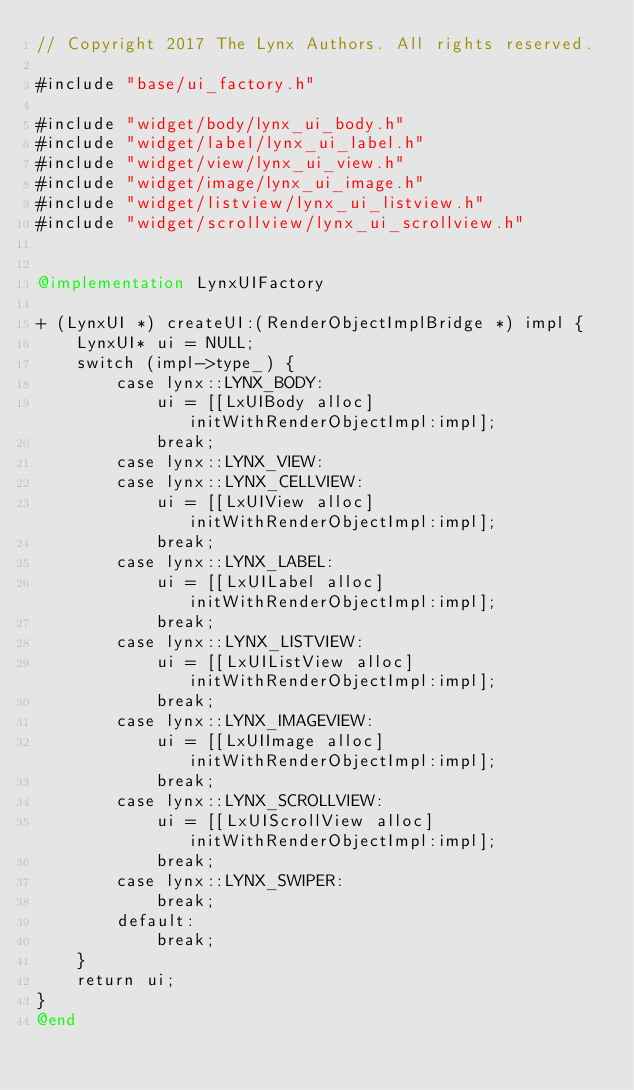<code> <loc_0><loc_0><loc_500><loc_500><_ObjectiveC_>// Copyright 2017 The Lynx Authors. All rights reserved.

#include "base/ui_factory.h"

#include "widget/body/lynx_ui_body.h"
#include "widget/label/lynx_ui_label.h"
#include "widget/view/lynx_ui_view.h"
#include "widget/image/lynx_ui_image.h"
#include "widget/listview/lynx_ui_listview.h"
#include "widget/scrollview/lynx_ui_scrollview.h"


@implementation LynxUIFactory

+ (LynxUI *) createUI:(RenderObjectImplBridge *) impl {
    LynxUI* ui = NULL;
    switch (impl->type_) {
        case lynx::LYNX_BODY:
            ui = [[LxUIBody alloc] initWithRenderObjectImpl:impl];
            break;
        case lynx::LYNX_VIEW:
        case lynx::LYNX_CELLVIEW:
            ui = [[LxUIView alloc] initWithRenderObjectImpl:impl];
            break;
        case lynx::LYNX_LABEL:
            ui = [[LxUILabel alloc] initWithRenderObjectImpl:impl];
            break;
        case lynx::LYNX_LISTVIEW:
            ui = [[LxUIListView alloc] initWithRenderObjectImpl:impl];
            break;
        case lynx::LYNX_IMAGEVIEW:
            ui = [[LxUIImage alloc] initWithRenderObjectImpl:impl];
            break;
        case lynx::LYNX_SCROLLVIEW:
            ui = [[LxUIScrollView alloc] initWithRenderObjectImpl:impl];
            break;
        case lynx::LYNX_SWIPER:
            break;
        default:
            break;
    }
    return ui;
}
@end
</code> 